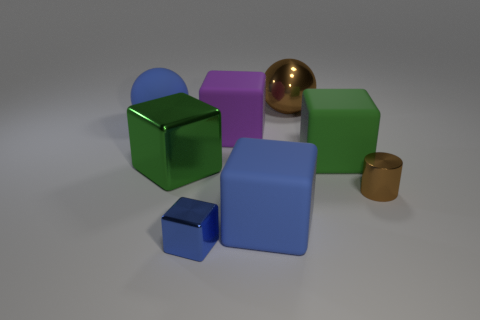There is a thing that is right of the brown ball and behind the tiny brown cylinder; what shape is it?
Make the answer very short. Cube. How many metallic objects are the same color as the large metallic ball?
Offer a terse response. 1. Are there any rubber spheres in front of the large rubber sphere that is on the left side of the matte object that is on the right side of the big brown metal ball?
Your answer should be very brief. No. How big is the cube that is both left of the big purple block and in front of the big green shiny block?
Your response must be concise. Small. How many other big cyan cylinders are made of the same material as the cylinder?
Your answer should be compact. 0. How many spheres are either large blue matte things or brown things?
Your response must be concise. 2. There is a brown cylinder that is in front of the large green block to the right of the matte block that is in front of the small brown cylinder; how big is it?
Provide a succinct answer. Small. The big thing that is both in front of the purple thing and on the left side of the purple rubber thing is what color?
Give a very brief answer. Green. There is a blue metal thing; is it the same size as the blue rubber thing that is behind the tiny metallic cylinder?
Offer a terse response. No. Are there any other things that have the same shape as the tiny brown object?
Provide a succinct answer. No. 